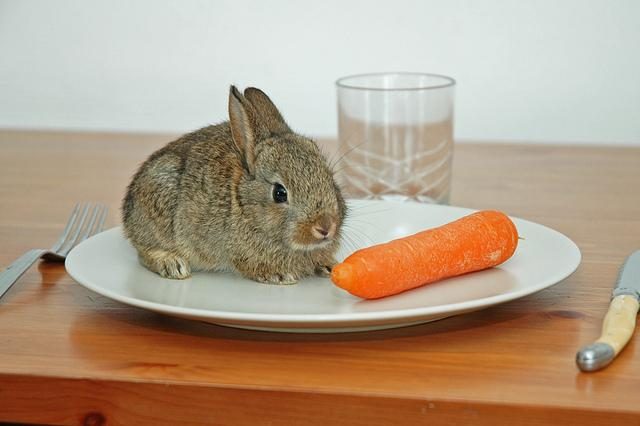What is the rabbit doing on the plate? eating 